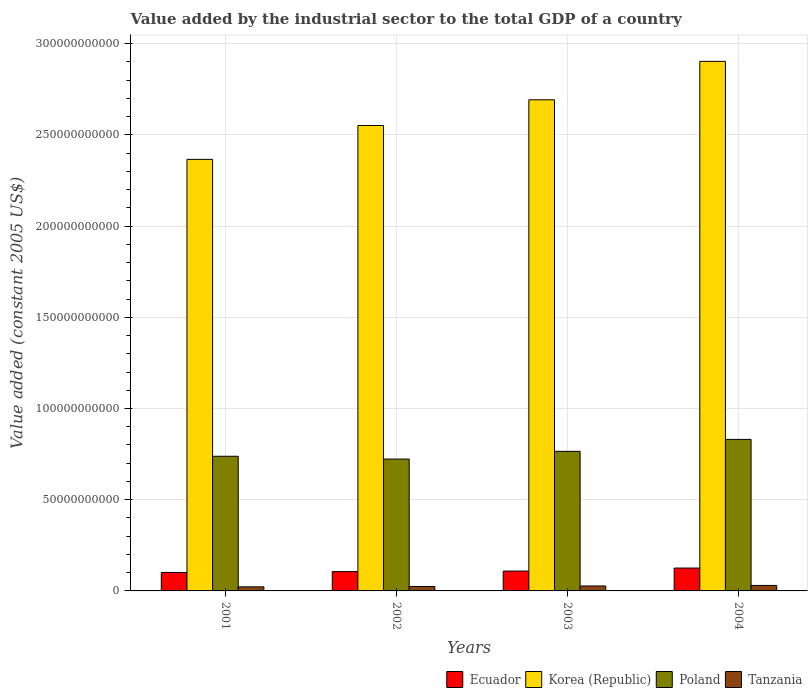How many different coloured bars are there?
Provide a succinct answer. 4. How many groups of bars are there?
Your answer should be very brief. 4. Are the number of bars on each tick of the X-axis equal?
Offer a terse response. Yes. How many bars are there on the 1st tick from the left?
Your answer should be very brief. 4. What is the label of the 2nd group of bars from the left?
Keep it short and to the point. 2002. What is the value added by the industrial sector in Poland in 2002?
Ensure brevity in your answer.  7.23e+1. Across all years, what is the maximum value added by the industrial sector in Korea (Republic)?
Ensure brevity in your answer.  2.90e+11. Across all years, what is the minimum value added by the industrial sector in Ecuador?
Make the answer very short. 1.01e+1. In which year was the value added by the industrial sector in Korea (Republic) maximum?
Ensure brevity in your answer.  2004. In which year was the value added by the industrial sector in Tanzania minimum?
Keep it short and to the point. 2001. What is the total value added by the industrial sector in Poland in the graph?
Provide a short and direct response. 3.06e+11. What is the difference between the value added by the industrial sector in Korea (Republic) in 2002 and that in 2004?
Offer a terse response. -3.52e+1. What is the difference between the value added by the industrial sector in Ecuador in 2001 and the value added by the industrial sector in Tanzania in 2002?
Offer a very short reply. 7.69e+09. What is the average value added by the industrial sector in Poland per year?
Offer a very short reply. 7.64e+1. In the year 2002, what is the difference between the value added by the industrial sector in Poland and value added by the industrial sector in Korea (Republic)?
Your answer should be compact. -1.83e+11. In how many years, is the value added by the industrial sector in Korea (Republic) greater than 210000000000 US$?
Make the answer very short. 4. What is the ratio of the value added by the industrial sector in Ecuador in 2001 to that in 2002?
Provide a succinct answer. 0.96. Is the value added by the industrial sector in Korea (Republic) in 2001 less than that in 2002?
Give a very brief answer. Yes. Is the difference between the value added by the industrial sector in Poland in 2001 and 2002 greater than the difference between the value added by the industrial sector in Korea (Republic) in 2001 and 2002?
Provide a succinct answer. Yes. What is the difference between the highest and the second highest value added by the industrial sector in Ecuador?
Keep it short and to the point. 1.66e+09. What is the difference between the highest and the lowest value added by the industrial sector in Tanzania?
Offer a terse response. 7.72e+08. In how many years, is the value added by the industrial sector in Ecuador greater than the average value added by the industrial sector in Ecuador taken over all years?
Offer a very short reply. 1. Is the sum of the value added by the industrial sector in Korea (Republic) in 2002 and 2003 greater than the maximum value added by the industrial sector in Tanzania across all years?
Ensure brevity in your answer.  Yes. What does the 1st bar from the left in 2004 represents?
Provide a short and direct response. Ecuador. What does the 3rd bar from the right in 2002 represents?
Ensure brevity in your answer.  Korea (Republic). Is it the case that in every year, the sum of the value added by the industrial sector in Tanzania and value added by the industrial sector in Ecuador is greater than the value added by the industrial sector in Korea (Republic)?
Give a very brief answer. No. How many bars are there?
Offer a very short reply. 16. Does the graph contain any zero values?
Offer a very short reply. No. Where does the legend appear in the graph?
Provide a succinct answer. Bottom right. How are the legend labels stacked?
Your response must be concise. Horizontal. What is the title of the graph?
Make the answer very short. Value added by the industrial sector to the total GDP of a country. What is the label or title of the Y-axis?
Provide a succinct answer. Value added (constant 2005 US$). What is the Value added (constant 2005 US$) in Ecuador in 2001?
Your response must be concise. 1.01e+1. What is the Value added (constant 2005 US$) of Korea (Republic) in 2001?
Give a very brief answer. 2.37e+11. What is the Value added (constant 2005 US$) in Poland in 2001?
Keep it short and to the point. 7.38e+1. What is the Value added (constant 2005 US$) in Tanzania in 2001?
Ensure brevity in your answer.  2.23e+09. What is the Value added (constant 2005 US$) in Ecuador in 2002?
Make the answer very short. 1.06e+1. What is the Value added (constant 2005 US$) in Korea (Republic) in 2002?
Offer a terse response. 2.55e+11. What is the Value added (constant 2005 US$) in Poland in 2002?
Give a very brief answer. 7.23e+1. What is the Value added (constant 2005 US$) of Tanzania in 2002?
Provide a succinct answer. 2.44e+09. What is the Value added (constant 2005 US$) of Ecuador in 2003?
Give a very brief answer. 1.09e+1. What is the Value added (constant 2005 US$) of Korea (Republic) in 2003?
Make the answer very short. 2.69e+11. What is the Value added (constant 2005 US$) in Poland in 2003?
Your answer should be very brief. 7.65e+1. What is the Value added (constant 2005 US$) in Tanzania in 2003?
Keep it short and to the point. 2.71e+09. What is the Value added (constant 2005 US$) of Ecuador in 2004?
Ensure brevity in your answer.  1.25e+1. What is the Value added (constant 2005 US$) in Korea (Republic) in 2004?
Your answer should be very brief. 2.90e+11. What is the Value added (constant 2005 US$) of Poland in 2004?
Provide a short and direct response. 8.31e+1. What is the Value added (constant 2005 US$) of Tanzania in 2004?
Offer a terse response. 3.01e+09. Across all years, what is the maximum Value added (constant 2005 US$) of Ecuador?
Provide a short and direct response. 1.25e+1. Across all years, what is the maximum Value added (constant 2005 US$) in Korea (Republic)?
Ensure brevity in your answer.  2.90e+11. Across all years, what is the maximum Value added (constant 2005 US$) of Poland?
Provide a short and direct response. 8.31e+1. Across all years, what is the maximum Value added (constant 2005 US$) in Tanzania?
Offer a very short reply. 3.01e+09. Across all years, what is the minimum Value added (constant 2005 US$) of Ecuador?
Your response must be concise. 1.01e+1. Across all years, what is the minimum Value added (constant 2005 US$) in Korea (Republic)?
Keep it short and to the point. 2.37e+11. Across all years, what is the minimum Value added (constant 2005 US$) in Poland?
Give a very brief answer. 7.23e+1. Across all years, what is the minimum Value added (constant 2005 US$) in Tanzania?
Ensure brevity in your answer.  2.23e+09. What is the total Value added (constant 2005 US$) of Ecuador in the graph?
Provide a short and direct response. 4.41e+1. What is the total Value added (constant 2005 US$) in Korea (Republic) in the graph?
Your answer should be very brief. 1.05e+12. What is the total Value added (constant 2005 US$) of Poland in the graph?
Offer a very short reply. 3.06e+11. What is the total Value added (constant 2005 US$) of Tanzania in the graph?
Your answer should be compact. 1.04e+1. What is the difference between the Value added (constant 2005 US$) of Ecuador in 2001 and that in 2002?
Provide a short and direct response. -4.61e+08. What is the difference between the Value added (constant 2005 US$) of Korea (Republic) in 2001 and that in 2002?
Offer a very short reply. -1.86e+1. What is the difference between the Value added (constant 2005 US$) in Poland in 2001 and that in 2002?
Make the answer very short. 1.53e+09. What is the difference between the Value added (constant 2005 US$) in Tanzania in 2001 and that in 2002?
Provide a short and direct response. -2.09e+08. What is the difference between the Value added (constant 2005 US$) in Ecuador in 2001 and that in 2003?
Make the answer very short. -7.50e+08. What is the difference between the Value added (constant 2005 US$) of Korea (Republic) in 2001 and that in 2003?
Your answer should be compact. -3.26e+1. What is the difference between the Value added (constant 2005 US$) of Poland in 2001 and that in 2003?
Give a very brief answer. -2.70e+09. What is the difference between the Value added (constant 2005 US$) in Tanzania in 2001 and that in 2003?
Keep it short and to the point. -4.77e+08. What is the difference between the Value added (constant 2005 US$) of Ecuador in 2001 and that in 2004?
Keep it short and to the point. -2.41e+09. What is the difference between the Value added (constant 2005 US$) of Korea (Republic) in 2001 and that in 2004?
Offer a very short reply. -5.37e+1. What is the difference between the Value added (constant 2005 US$) of Poland in 2001 and that in 2004?
Your answer should be very brief. -9.25e+09. What is the difference between the Value added (constant 2005 US$) in Tanzania in 2001 and that in 2004?
Ensure brevity in your answer.  -7.72e+08. What is the difference between the Value added (constant 2005 US$) in Ecuador in 2002 and that in 2003?
Your response must be concise. -2.89e+08. What is the difference between the Value added (constant 2005 US$) of Korea (Republic) in 2002 and that in 2003?
Provide a short and direct response. -1.41e+1. What is the difference between the Value added (constant 2005 US$) of Poland in 2002 and that in 2003?
Offer a very short reply. -4.23e+09. What is the difference between the Value added (constant 2005 US$) of Tanzania in 2002 and that in 2003?
Offer a very short reply. -2.67e+08. What is the difference between the Value added (constant 2005 US$) of Ecuador in 2002 and that in 2004?
Keep it short and to the point. -1.94e+09. What is the difference between the Value added (constant 2005 US$) in Korea (Republic) in 2002 and that in 2004?
Keep it short and to the point. -3.52e+1. What is the difference between the Value added (constant 2005 US$) in Poland in 2002 and that in 2004?
Offer a terse response. -1.08e+1. What is the difference between the Value added (constant 2005 US$) in Tanzania in 2002 and that in 2004?
Your answer should be compact. -5.63e+08. What is the difference between the Value added (constant 2005 US$) in Ecuador in 2003 and that in 2004?
Offer a very short reply. -1.66e+09. What is the difference between the Value added (constant 2005 US$) of Korea (Republic) in 2003 and that in 2004?
Offer a very short reply. -2.11e+1. What is the difference between the Value added (constant 2005 US$) in Poland in 2003 and that in 2004?
Your answer should be compact. -6.55e+09. What is the difference between the Value added (constant 2005 US$) in Tanzania in 2003 and that in 2004?
Offer a very short reply. -2.95e+08. What is the difference between the Value added (constant 2005 US$) in Ecuador in 2001 and the Value added (constant 2005 US$) in Korea (Republic) in 2002?
Offer a terse response. -2.45e+11. What is the difference between the Value added (constant 2005 US$) of Ecuador in 2001 and the Value added (constant 2005 US$) of Poland in 2002?
Offer a very short reply. -6.21e+1. What is the difference between the Value added (constant 2005 US$) in Ecuador in 2001 and the Value added (constant 2005 US$) in Tanzania in 2002?
Provide a short and direct response. 7.69e+09. What is the difference between the Value added (constant 2005 US$) of Korea (Republic) in 2001 and the Value added (constant 2005 US$) of Poland in 2002?
Provide a short and direct response. 1.64e+11. What is the difference between the Value added (constant 2005 US$) of Korea (Republic) in 2001 and the Value added (constant 2005 US$) of Tanzania in 2002?
Give a very brief answer. 2.34e+11. What is the difference between the Value added (constant 2005 US$) of Poland in 2001 and the Value added (constant 2005 US$) of Tanzania in 2002?
Give a very brief answer. 7.14e+1. What is the difference between the Value added (constant 2005 US$) in Ecuador in 2001 and the Value added (constant 2005 US$) in Korea (Republic) in 2003?
Your response must be concise. -2.59e+11. What is the difference between the Value added (constant 2005 US$) in Ecuador in 2001 and the Value added (constant 2005 US$) in Poland in 2003?
Your answer should be very brief. -6.64e+1. What is the difference between the Value added (constant 2005 US$) in Ecuador in 2001 and the Value added (constant 2005 US$) in Tanzania in 2003?
Offer a very short reply. 7.42e+09. What is the difference between the Value added (constant 2005 US$) of Korea (Republic) in 2001 and the Value added (constant 2005 US$) of Poland in 2003?
Ensure brevity in your answer.  1.60e+11. What is the difference between the Value added (constant 2005 US$) of Korea (Republic) in 2001 and the Value added (constant 2005 US$) of Tanzania in 2003?
Provide a succinct answer. 2.34e+11. What is the difference between the Value added (constant 2005 US$) in Poland in 2001 and the Value added (constant 2005 US$) in Tanzania in 2003?
Give a very brief answer. 7.11e+1. What is the difference between the Value added (constant 2005 US$) in Ecuador in 2001 and the Value added (constant 2005 US$) in Korea (Republic) in 2004?
Your response must be concise. -2.80e+11. What is the difference between the Value added (constant 2005 US$) in Ecuador in 2001 and the Value added (constant 2005 US$) in Poland in 2004?
Keep it short and to the point. -7.29e+1. What is the difference between the Value added (constant 2005 US$) of Ecuador in 2001 and the Value added (constant 2005 US$) of Tanzania in 2004?
Provide a succinct answer. 7.13e+09. What is the difference between the Value added (constant 2005 US$) in Korea (Republic) in 2001 and the Value added (constant 2005 US$) in Poland in 2004?
Your answer should be compact. 1.54e+11. What is the difference between the Value added (constant 2005 US$) of Korea (Republic) in 2001 and the Value added (constant 2005 US$) of Tanzania in 2004?
Your answer should be very brief. 2.34e+11. What is the difference between the Value added (constant 2005 US$) of Poland in 2001 and the Value added (constant 2005 US$) of Tanzania in 2004?
Your answer should be compact. 7.08e+1. What is the difference between the Value added (constant 2005 US$) in Ecuador in 2002 and the Value added (constant 2005 US$) in Korea (Republic) in 2003?
Provide a succinct answer. -2.59e+11. What is the difference between the Value added (constant 2005 US$) of Ecuador in 2002 and the Value added (constant 2005 US$) of Poland in 2003?
Give a very brief answer. -6.59e+1. What is the difference between the Value added (constant 2005 US$) in Ecuador in 2002 and the Value added (constant 2005 US$) in Tanzania in 2003?
Offer a very short reply. 7.88e+09. What is the difference between the Value added (constant 2005 US$) in Korea (Republic) in 2002 and the Value added (constant 2005 US$) in Poland in 2003?
Your response must be concise. 1.79e+11. What is the difference between the Value added (constant 2005 US$) in Korea (Republic) in 2002 and the Value added (constant 2005 US$) in Tanzania in 2003?
Offer a very short reply. 2.52e+11. What is the difference between the Value added (constant 2005 US$) in Poland in 2002 and the Value added (constant 2005 US$) in Tanzania in 2003?
Offer a terse response. 6.96e+1. What is the difference between the Value added (constant 2005 US$) in Ecuador in 2002 and the Value added (constant 2005 US$) in Korea (Republic) in 2004?
Provide a succinct answer. -2.80e+11. What is the difference between the Value added (constant 2005 US$) of Ecuador in 2002 and the Value added (constant 2005 US$) of Poland in 2004?
Your answer should be very brief. -7.25e+1. What is the difference between the Value added (constant 2005 US$) in Ecuador in 2002 and the Value added (constant 2005 US$) in Tanzania in 2004?
Ensure brevity in your answer.  7.59e+09. What is the difference between the Value added (constant 2005 US$) of Korea (Republic) in 2002 and the Value added (constant 2005 US$) of Poland in 2004?
Provide a succinct answer. 1.72e+11. What is the difference between the Value added (constant 2005 US$) in Korea (Republic) in 2002 and the Value added (constant 2005 US$) in Tanzania in 2004?
Your answer should be very brief. 2.52e+11. What is the difference between the Value added (constant 2005 US$) in Poland in 2002 and the Value added (constant 2005 US$) in Tanzania in 2004?
Your answer should be compact. 6.93e+1. What is the difference between the Value added (constant 2005 US$) in Ecuador in 2003 and the Value added (constant 2005 US$) in Korea (Republic) in 2004?
Your answer should be very brief. -2.79e+11. What is the difference between the Value added (constant 2005 US$) in Ecuador in 2003 and the Value added (constant 2005 US$) in Poland in 2004?
Your answer should be very brief. -7.22e+1. What is the difference between the Value added (constant 2005 US$) of Ecuador in 2003 and the Value added (constant 2005 US$) of Tanzania in 2004?
Offer a very short reply. 7.88e+09. What is the difference between the Value added (constant 2005 US$) in Korea (Republic) in 2003 and the Value added (constant 2005 US$) in Poland in 2004?
Keep it short and to the point. 1.86e+11. What is the difference between the Value added (constant 2005 US$) of Korea (Republic) in 2003 and the Value added (constant 2005 US$) of Tanzania in 2004?
Make the answer very short. 2.66e+11. What is the difference between the Value added (constant 2005 US$) in Poland in 2003 and the Value added (constant 2005 US$) in Tanzania in 2004?
Provide a short and direct response. 7.35e+1. What is the average Value added (constant 2005 US$) in Ecuador per year?
Your answer should be compact. 1.10e+1. What is the average Value added (constant 2005 US$) in Korea (Republic) per year?
Your answer should be very brief. 2.63e+11. What is the average Value added (constant 2005 US$) in Poland per year?
Provide a succinct answer. 7.64e+1. What is the average Value added (constant 2005 US$) in Tanzania per year?
Keep it short and to the point. 2.60e+09. In the year 2001, what is the difference between the Value added (constant 2005 US$) in Ecuador and Value added (constant 2005 US$) in Korea (Republic)?
Offer a terse response. -2.26e+11. In the year 2001, what is the difference between the Value added (constant 2005 US$) in Ecuador and Value added (constant 2005 US$) in Poland?
Your answer should be very brief. -6.37e+1. In the year 2001, what is the difference between the Value added (constant 2005 US$) in Ecuador and Value added (constant 2005 US$) in Tanzania?
Keep it short and to the point. 7.90e+09. In the year 2001, what is the difference between the Value added (constant 2005 US$) of Korea (Republic) and Value added (constant 2005 US$) of Poland?
Keep it short and to the point. 1.63e+11. In the year 2001, what is the difference between the Value added (constant 2005 US$) of Korea (Republic) and Value added (constant 2005 US$) of Tanzania?
Provide a short and direct response. 2.34e+11. In the year 2001, what is the difference between the Value added (constant 2005 US$) in Poland and Value added (constant 2005 US$) in Tanzania?
Give a very brief answer. 7.16e+1. In the year 2002, what is the difference between the Value added (constant 2005 US$) of Ecuador and Value added (constant 2005 US$) of Korea (Republic)?
Ensure brevity in your answer.  -2.45e+11. In the year 2002, what is the difference between the Value added (constant 2005 US$) of Ecuador and Value added (constant 2005 US$) of Poland?
Your answer should be compact. -6.17e+1. In the year 2002, what is the difference between the Value added (constant 2005 US$) in Ecuador and Value added (constant 2005 US$) in Tanzania?
Offer a terse response. 8.15e+09. In the year 2002, what is the difference between the Value added (constant 2005 US$) of Korea (Republic) and Value added (constant 2005 US$) of Poland?
Ensure brevity in your answer.  1.83e+11. In the year 2002, what is the difference between the Value added (constant 2005 US$) of Korea (Republic) and Value added (constant 2005 US$) of Tanzania?
Provide a short and direct response. 2.53e+11. In the year 2002, what is the difference between the Value added (constant 2005 US$) of Poland and Value added (constant 2005 US$) of Tanzania?
Provide a succinct answer. 6.98e+1. In the year 2003, what is the difference between the Value added (constant 2005 US$) in Ecuador and Value added (constant 2005 US$) in Korea (Republic)?
Your response must be concise. -2.58e+11. In the year 2003, what is the difference between the Value added (constant 2005 US$) in Ecuador and Value added (constant 2005 US$) in Poland?
Your answer should be very brief. -6.56e+1. In the year 2003, what is the difference between the Value added (constant 2005 US$) of Ecuador and Value added (constant 2005 US$) of Tanzania?
Provide a succinct answer. 8.17e+09. In the year 2003, what is the difference between the Value added (constant 2005 US$) of Korea (Republic) and Value added (constant 2005 US$) of Poland?
Provide a short and direct response. 1.93e+11. In the year 2003, what is the difference between the Value added (constant 2005 US$) of Korea (Republic) and Value added (constant 2005 US$) of Tanzania?
Your answer should be very brief. 2.67e+11. In the year 2003, what is the difference between the Value added (constant 2005 US$) in Poland and Value added (constant 2005 US$) in Tanzania?
Provide a succinct answer. 7.38e+1. In the year 2004, what is the difference between the Value added (constant 2005 US$) of Ecuador and Value added (constant 2005 US$) of Korea (Republic)?
Provide a short and direct response. -2.78e+11. In the year 2004, what is the difference between the Value added (constant 2005 US$) in Ecuador and Value added (constant 2005 US$) in Poland?
Offer a very short reply. -7.05e+1. In the year 2004, what is the difference between the Value added (constant 2005 US$) in Ecuador and Value added (constant 2005 US$) in Tanzania?
Give a very brief answer. 9.53e+09. In the year 2004, what is the difference between the Value added (constant 2005 US$) of Korea (Republic) and Value added (constant 2005 US$) of Poland?
Provide a short and direct response. 2.07e+11. In the year 2004, what is the difference between the Value added (constant 2005 US$) of Korea (Republic) and Value added (constant 2005 US$) of Tanzania?
Give a very brief answer. 2.87e+11. In the year 2004, what is the difference between the Value added (constant 2005 US$) in Poland and Value added (constant 2005 US$) in Tanzania?
Provide a short and direct response. 8.01e+1. What is the ratio of the Value added (constant 2005 US$) of Ecuador in 2001 to that in 2002?
Ensure brevity in your answer.  0.96. What is the ratio of the Value added (constant 2005 US$) in Korea (Republic) in 2001 to that in 2002?
Keep it short and to the point. 0.93. What is the ratio of the Value added (constant 2005 US$) in Poland in 2001 to that in 2002?
Give a very brief answer. 1.02. What is the ratio of the Value added (constant 2005 US$) of Tanzania in 2001 to that in 2002?
Give a very brief answer. 0.91. What is the ratio of the Value added (constant 2005 US$) of Ecuador in 2001 to that in 2003?
Offer a very short reply. 0.93. What is the ratio of the Value added (constant 2005 US$) of Korea (Republic) in 2001 to that in 2003?
Make the answer very short. 0.88. What is the ratio of the Value added (constant 2005 US$) in Poland in 2001 to that in 2003?
Keep it short and to the point. 0.96. What is the ratio of the Value added (constant 2005 US$) of Tanzania in 2001 to that in 2003?
Keep it short and to the point. 0.82. What is the ratio of the Value added (constant 2005 US$) of Ecuador in 2001 to that in 2004?
Offer a terse response. 0.81. What is the ratio of the Value added (constant 2005 US$) in Korea (Republic) in 2001 to that in 2004?
Offer a terse response. 0.81. What is the ratio of the Value added (constant 2005 US$) in Poland in 2001 to that in 2004?
Your response must be concise. 0.89. What is the ratio of the Value added (constant 2005 US$) in Tanzania in 2001 to that in 2004?
Provide a short and direct response. 0.74. What is the ratio of the Value added (constant 2005 US$) of Ecuador in 2002 to that in 2003?
Keep it short and to the point. 0.97. What is the ratio of the Value added (constant 2005 US$) of Korea (Republic) in 2002 to that in 2003?
Offer a terse response. 0.95. What is the ratio of the Value added (constant 2005 US$) of Poland in 2002 to that in 2003?
Make the answer very short. 0.94. What is the ratio of the Value added (constant 2005 US$) in Tanzania in 2002 to that in 2003?
Ensure brevity in your answer.  0.9. What is the ratio of the Value added (constant 2005 US$) of Ecuador in 2002 to that in 2004?
Provide a short and direct response. 0.84. What is the ratio of the Value added (constant 2005 US$) in Korea (Republic) in 2002 to that in 2004?
Your answer should be compact. 0.88. What is the ratio of the Value added (constant 2005 US$) in Poland in 2002 to that in 2004?
Offer a very short reply. 0.87. What is the ratio of the Value added (constant 2005 US$) of Tanzania in 2002 to that in 2004?
Keep it short and to the point. 0.81. What is the ratio of the Value added (constant 2005 US$) of Ecuador in 2003 to that in 2004?
Offer a terse response. 0.87. What is the ratio of the Value added (constant 2005 US$) in Korea (Republic) in 2003 to that in 2004?
Make the answer very short. 0.93. What is the ratio of the Value added (constant 2005 US$) of Poland in 2003 to that in 2004?
Offer a very short reply. 0.92. What is the ratio of the Value added (constant 2005 US$) in Tanzania in 2003 to that in 2004?
Give a very brief answer. 0.9. What is the difference between the highest and the second highest Value added (constant 2005 US$) of Ecuador?
Your response must be concise. 1.66e+09. What is the difference between the highest and the second highest Value added (constant 2005 US$) in Korea (Republic)?
Your answer should be compact. 2.11e+1. What is the difference between the highest and the second highest Value added (constant 2005 US$) in Poland?
Provide a succinct answer. 6.55e+09. What is the difference between the highest and the second highest Value added (constant 2005 US$) of Tanzania?
Make the answer very short. 2.95e+08. What is the difference between the highest and the lowest Value added (constant 2005 US$) of Ecuador?
Ensure brevity in your answer.  2.41e+09. What is the difference between the highest and the lowest Value added (constant 2005 US$) of Korea (Republic)?
Keep it short and to the point. 5.37e+1. What is the difference between the highest and the lowest Value added (constant 2005 US$) of Poland?
Your answer should be very brief. 1.08e+1. What is the difference between the highest and the lowest Value added (constant 2005 US$) of Tanzania?
Give a very brief answer. 7.72e+08. 